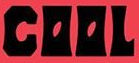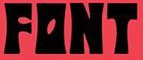What words are shown in these images in order, separated by a semicolon? COOL; FONT 